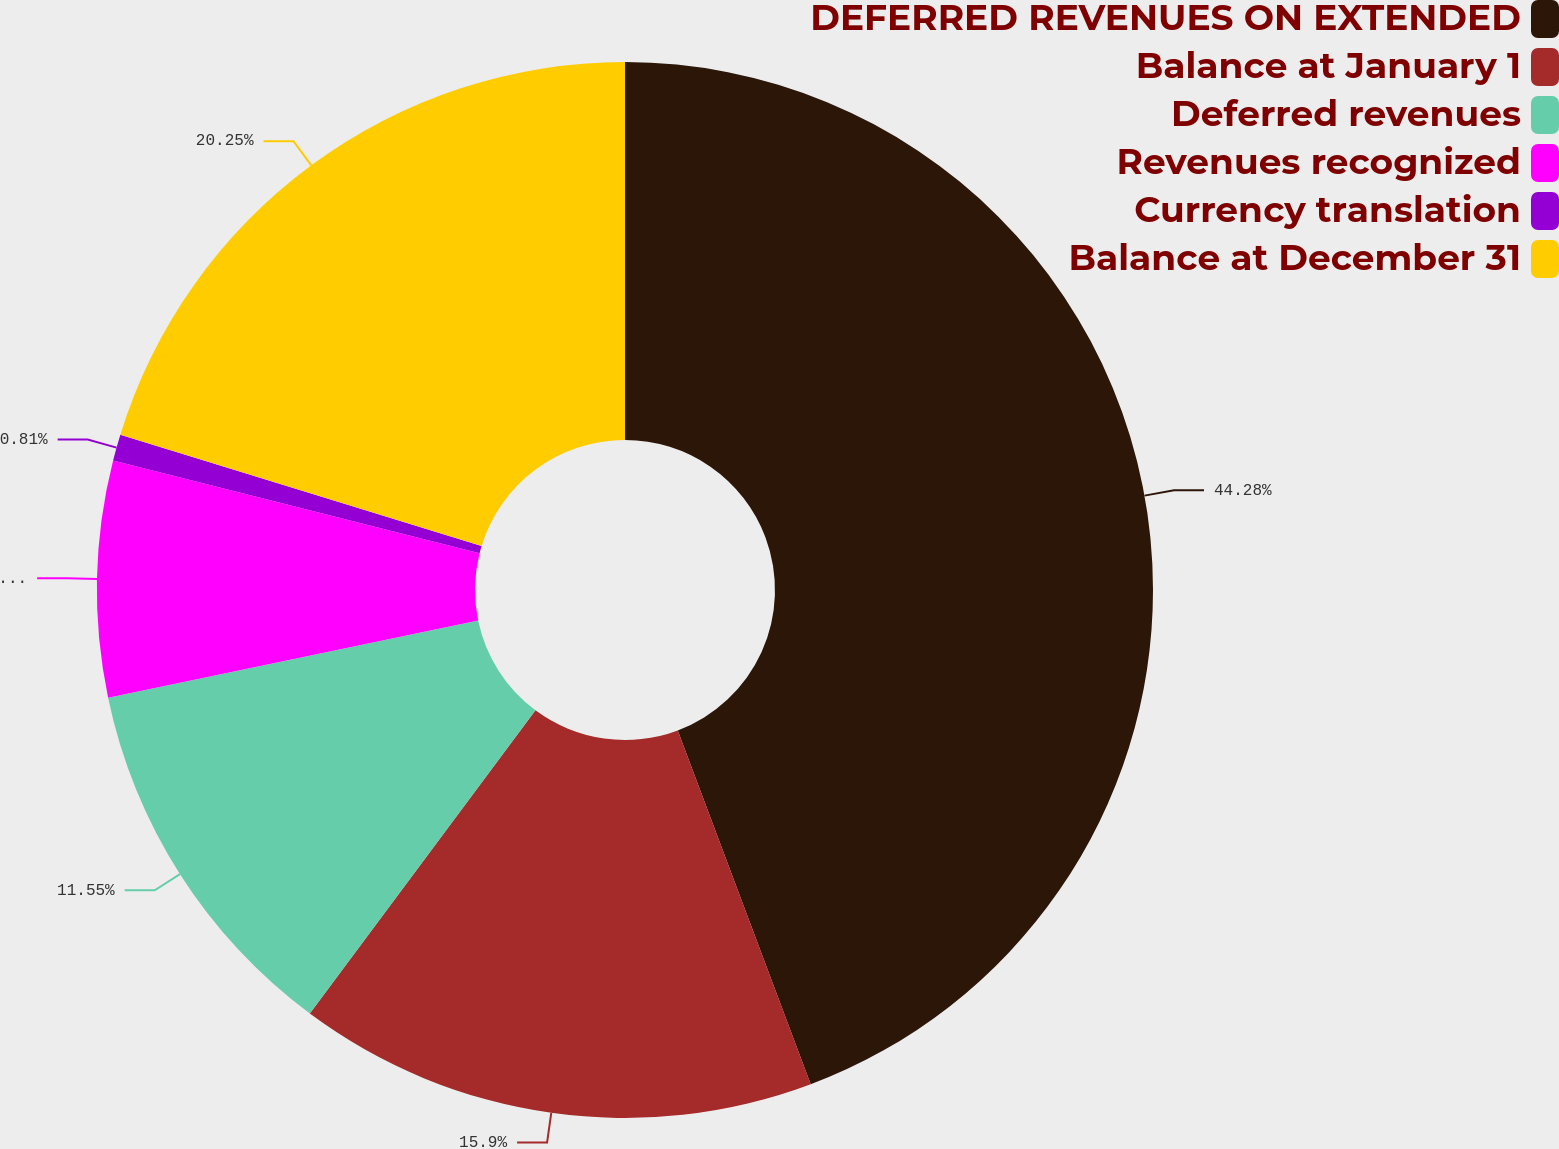Convert chart to OTSL. <chart><loc_0><loc_0><loc_500><loc_500><pie_chart><fcel>DEFERRED REVENUES ON EXTENDED<fcel>Balance at January 1<fcel>Deferred revenues<fcel>Revenues recognized<fcel>Currency translation<fcel>Balance at December 31<nl><fcel>44.28%<fcel>15.9%<fcel>11.55%<fcel>7.21%<fcel>0.81%<fcel>20.25%<nl></chart> 